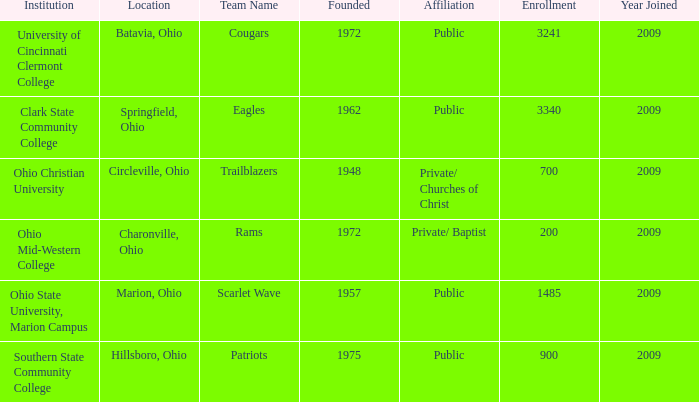What place was established in the year 1957? Marion, Ohio. Could you parse the entire table as a dict? {'header': ['Institution', 'Location', 'Team Name', 'Founded', 'Affiliation', 'Enrollment', 'Year Joined'], 'rows': [['University of Cincinnati Clermont College', 'Batavia, Ohio', 'Cougars', '1972', 'Public', '3241', '2009'], ['Clark State Community College', 'Springfield, Ohio', 'Eagles', '1962', 'Public', '3340', '2009'], ['Ohio Christian University', 'Circleville, Ohio', 'Trailblazers', '1948', 'Private/ Churches of Christ', '700', '2009'], ['Ohio Mid-Western College', 'Charonville, Ohio', 'Rams', '1972', 'Private/ Baptist', '200', '2009'], ['Ohio State University, Marion Campus', 'Marion, Ohio', 'Scarlet Wave', '1957', 'Public', '1485', '2009'], ['Southern State Community College', 'Hillsboro, Ohio', 'Patriots', '1975', 'Public', '900', '2009']]} 